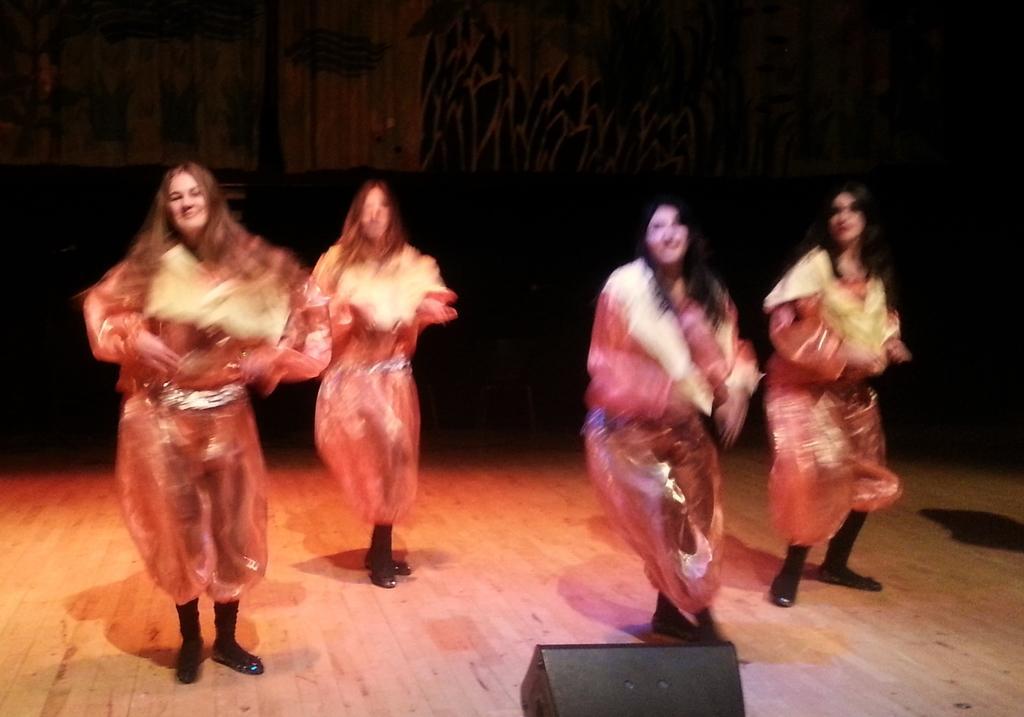Could you give a brief overview of what you see in this image? In the image there are four girls in shiny costume and black shoe dancing on the wooden floor with a light in the middle, behind them there is a wall. 